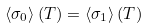Convert formula to latex. <formula><loc_0><loc_0><loc_500><loc_500>\left < \sigma _ { 0 } \right > ( T ) = \left < \sigma _ { 1 } \right > ( T )</formula> 